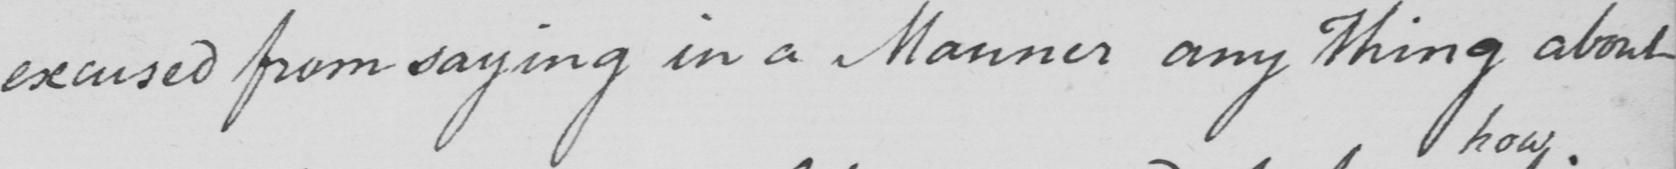Transcribe the text shown in this historical manuscript line. excused from saying in a Manner any thing about 